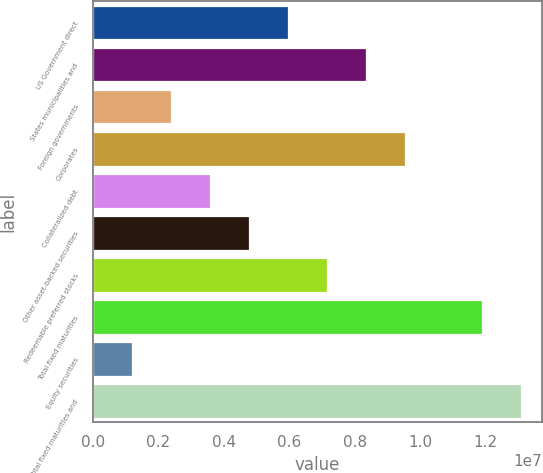Convert chart. <chart><loc_0><loc_0><loc_500><loc_500><bar_chart><fcel>US Government direct<fcel>States municipalities and<fcel>Foreign governments<fcel>Corporates<fcel>Collateralized debt<fcel>Other asset-backed securities<fcel>Redeemable preferred stocks<fcel>Total fixed maturities<fcel>Equity securities<fcel>Total fixed maturities and<nl><fcel>5.95268e+06<fcel>8.33371e+06<fcel>2.38113e+06<fcel>9.52423e+06<fcel>3.57165e+06<fcel>4.76216e+06<fcel>7.1432e+06<fcel>1.18882e+07<fcel>1.19062e+06<fcel>1.30787e+07<nl></chart> 